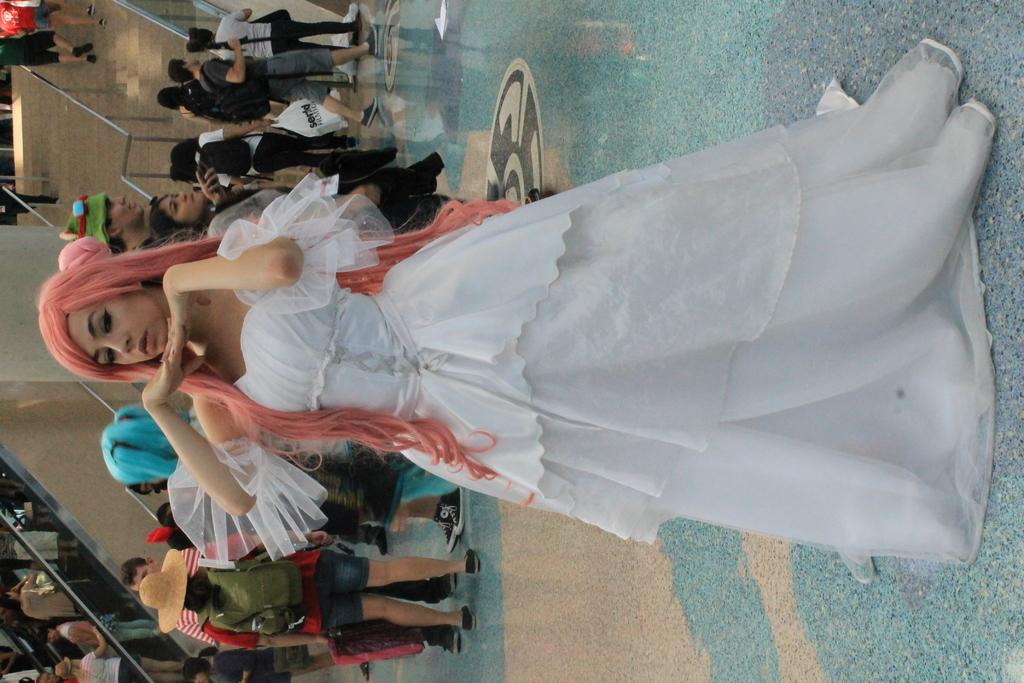Who is the main subject in the image? There is a woman in the image. What is the woman doing in the image? The woman is standing. What is the woman wearing in the image? The woman is wearing a white dress. What can be seen in the background of the image? There are people walking in the background of the image. What type of kite is the woman holding in the image? There is no kite present in the image. How much debt does the woman have in the image? There is no information about the woman's debt in the image. 